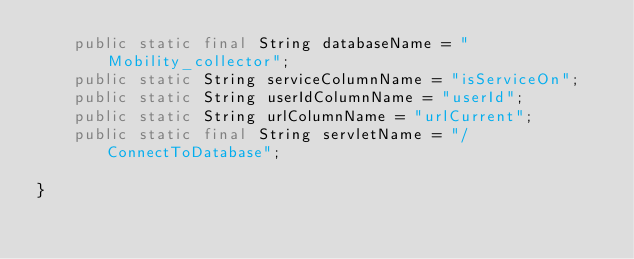Convert code to text. <code><loc_0><loc_0><loc_500><loc_500><_Java_>	public static final String databaseName = "Mobility_collector";
	public static String serviceColumnName = "isServiceOn";
	public static String userIdColumnName = "userId";
	public static String urlColumnName = "urlCurrent";
	public static final String servletName = "/ConnectToDatabase";
	
}
</code> 